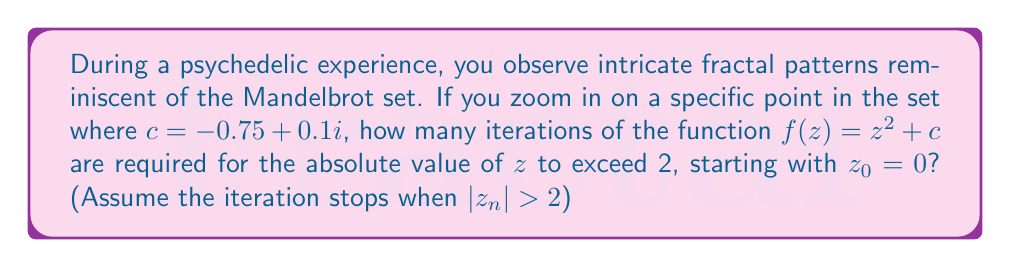Show me your answer to this math problem. To solve this problem, we need to iterate the function $f(z) = z^2 + c$ with $c = -0.75 + 0.1i$ and $z_0 = 0$, until $|z_n| > 2$. Let's calculate step by step:

1) Start with $z_0 = 0$

2) First iteration:
   $z_1 = z_0^2 + c = 0^2 + (-0.75 + 0.1i) = -0.75 + 0.1i$
   $|z_1| = \sqrt{(-0.75)^2 + 0.1^2} \approx 0.7566 < 2$

3) Second iteration:
   $z_2 = z_1^2 + c = (-0.75 + 0.1i)^2 + (-0.75 + 0.1i)$
        $= (0.5625 - 0.15i + 0.01i^2) + (-0.75 + 0.1i)$
        $= -0.1875 - 0.05i$
   $|z_2| = \sqrt{(-0.1875)^2 + (-0.05)^2} \approx 0.1944 < 2$

4) Third iteration:
   $z_3 = z_2^2 + c = (-0.1875 - 0.05i)^2 + (-0.75 + 0.1i)$
        $= (0.0352 + 0.0188i) + (-0.75 + 0.1i)$
        $= -0.7148 + 0.1188i$
   $|z_3| = \sqrt{(-0.7148)^2 + 0.1188^2} \approx 0.7245 < 2$

5) Fourth iteration:
   $z_4 = z_3^2 + c = (-0.7148 + 0.1188i)^2 + (-0.75 + 0.1i)$
        $= (0.5109 - 0.1698i) + (-0.75 + 0.1i)$
        $= -0.2391 - 0.0698i$
   $|z_4| = \sqrt{(-0.2391)^2 + (-0.0698)^2} \approx 0.2489 < 2$

6) Fifth iteration:
   $z_5 = z_4^2 + c = (-0.2391 - 0.0698i)^2 + (-0.75 + 0.1i)$
        $= (0.0572 + 0.0334i) + (-0.75 + 0.1i)$
        $= -0.6928 + 0.1334i$
   $|z_5| = \sqrt{(-0.6928)^2 + 0.1334^2} \approx 0.7056 < 2$

7) Sixth iteration:
   $z_6 = z_5^2 + c = (-0.6928 + 0.1334i)^2 + (-0.75 + 0.1i)$
        $= (0.4800 - 0.1848i) + (-0.75 + 0.1i)$
        $= -0.2700 - 0.0848i$
   $|z_6| = \sqrt{(-0.2700)^2 + (-0.0848)^2} \approx 0.2828 < 2$

8) Seventh iteration:
   $z_7 = z_6^2 + c = (-0.2700 - 0.0848i)^2 + (-0.75 + 0.1i)$
        $= (0.0729 + 0.0458i) + (-0.75 + 0.1i)$
        $= -0.6771 + 0.1458i$
   $|z_7| = \sqrt{(-0.6771)^2 + 0.1458^2} \approx 0.6929 < 2$

9) Eighth iteration:
   $z_8 = z_7^2 + c = (-0.6771 + 0.1458i)^2 + (-0.75 + 0.1i)$
        $= (0.4585 - 0.1975i) + (-0.75 + 0.1i)$
        $= -0.2915 - 0.0975i$
   $|z_8| = \sqrt{(-0.2915)^2 + (-0.0975)^2} \approx 0.3074 < 2$

10) Ninth iteration:
    $z_9 = z_8^2 + c = (-0.2915 - 0.0975i)^2 + (-0.75 + 0.1i)$
         $= (0.0850 + 0.0568i) + (-0.75 + 0.1i)$
         $= -0.6650 + 0.1568i$
    $|z_9| = \sqrt{(-0.6650)^2 + 0.1568^2} \approx 0.6837 < 2$

11) Tenth iteration:
    $z_{10} = z_9^2 + c = (-0.6650 + 0.1568i)^2 + (-0.75 + 0.1i)$
            $= (0.4422 - 0.2085i) + (-0.75 + 0.1i)$
            $= -0.3078 - 0.1085i$
    $|z_{10}| = \sqrt{(-0.3078)^2 + (-0.1085)^2} \approx 0.3266 < 2$

The process continues, but we can see that after 10 iterations, $|z_n|$ is still less than 2. In fact, for this particular point $c = -0.75 + 0.1i$, the iterations will never exceed 2, as this point is within the Mandelbrot set.
Answer: The iterations will never exceed 2 for $c = -0.75 + 0.1i$, as this point is within the Mandelbrot set. 